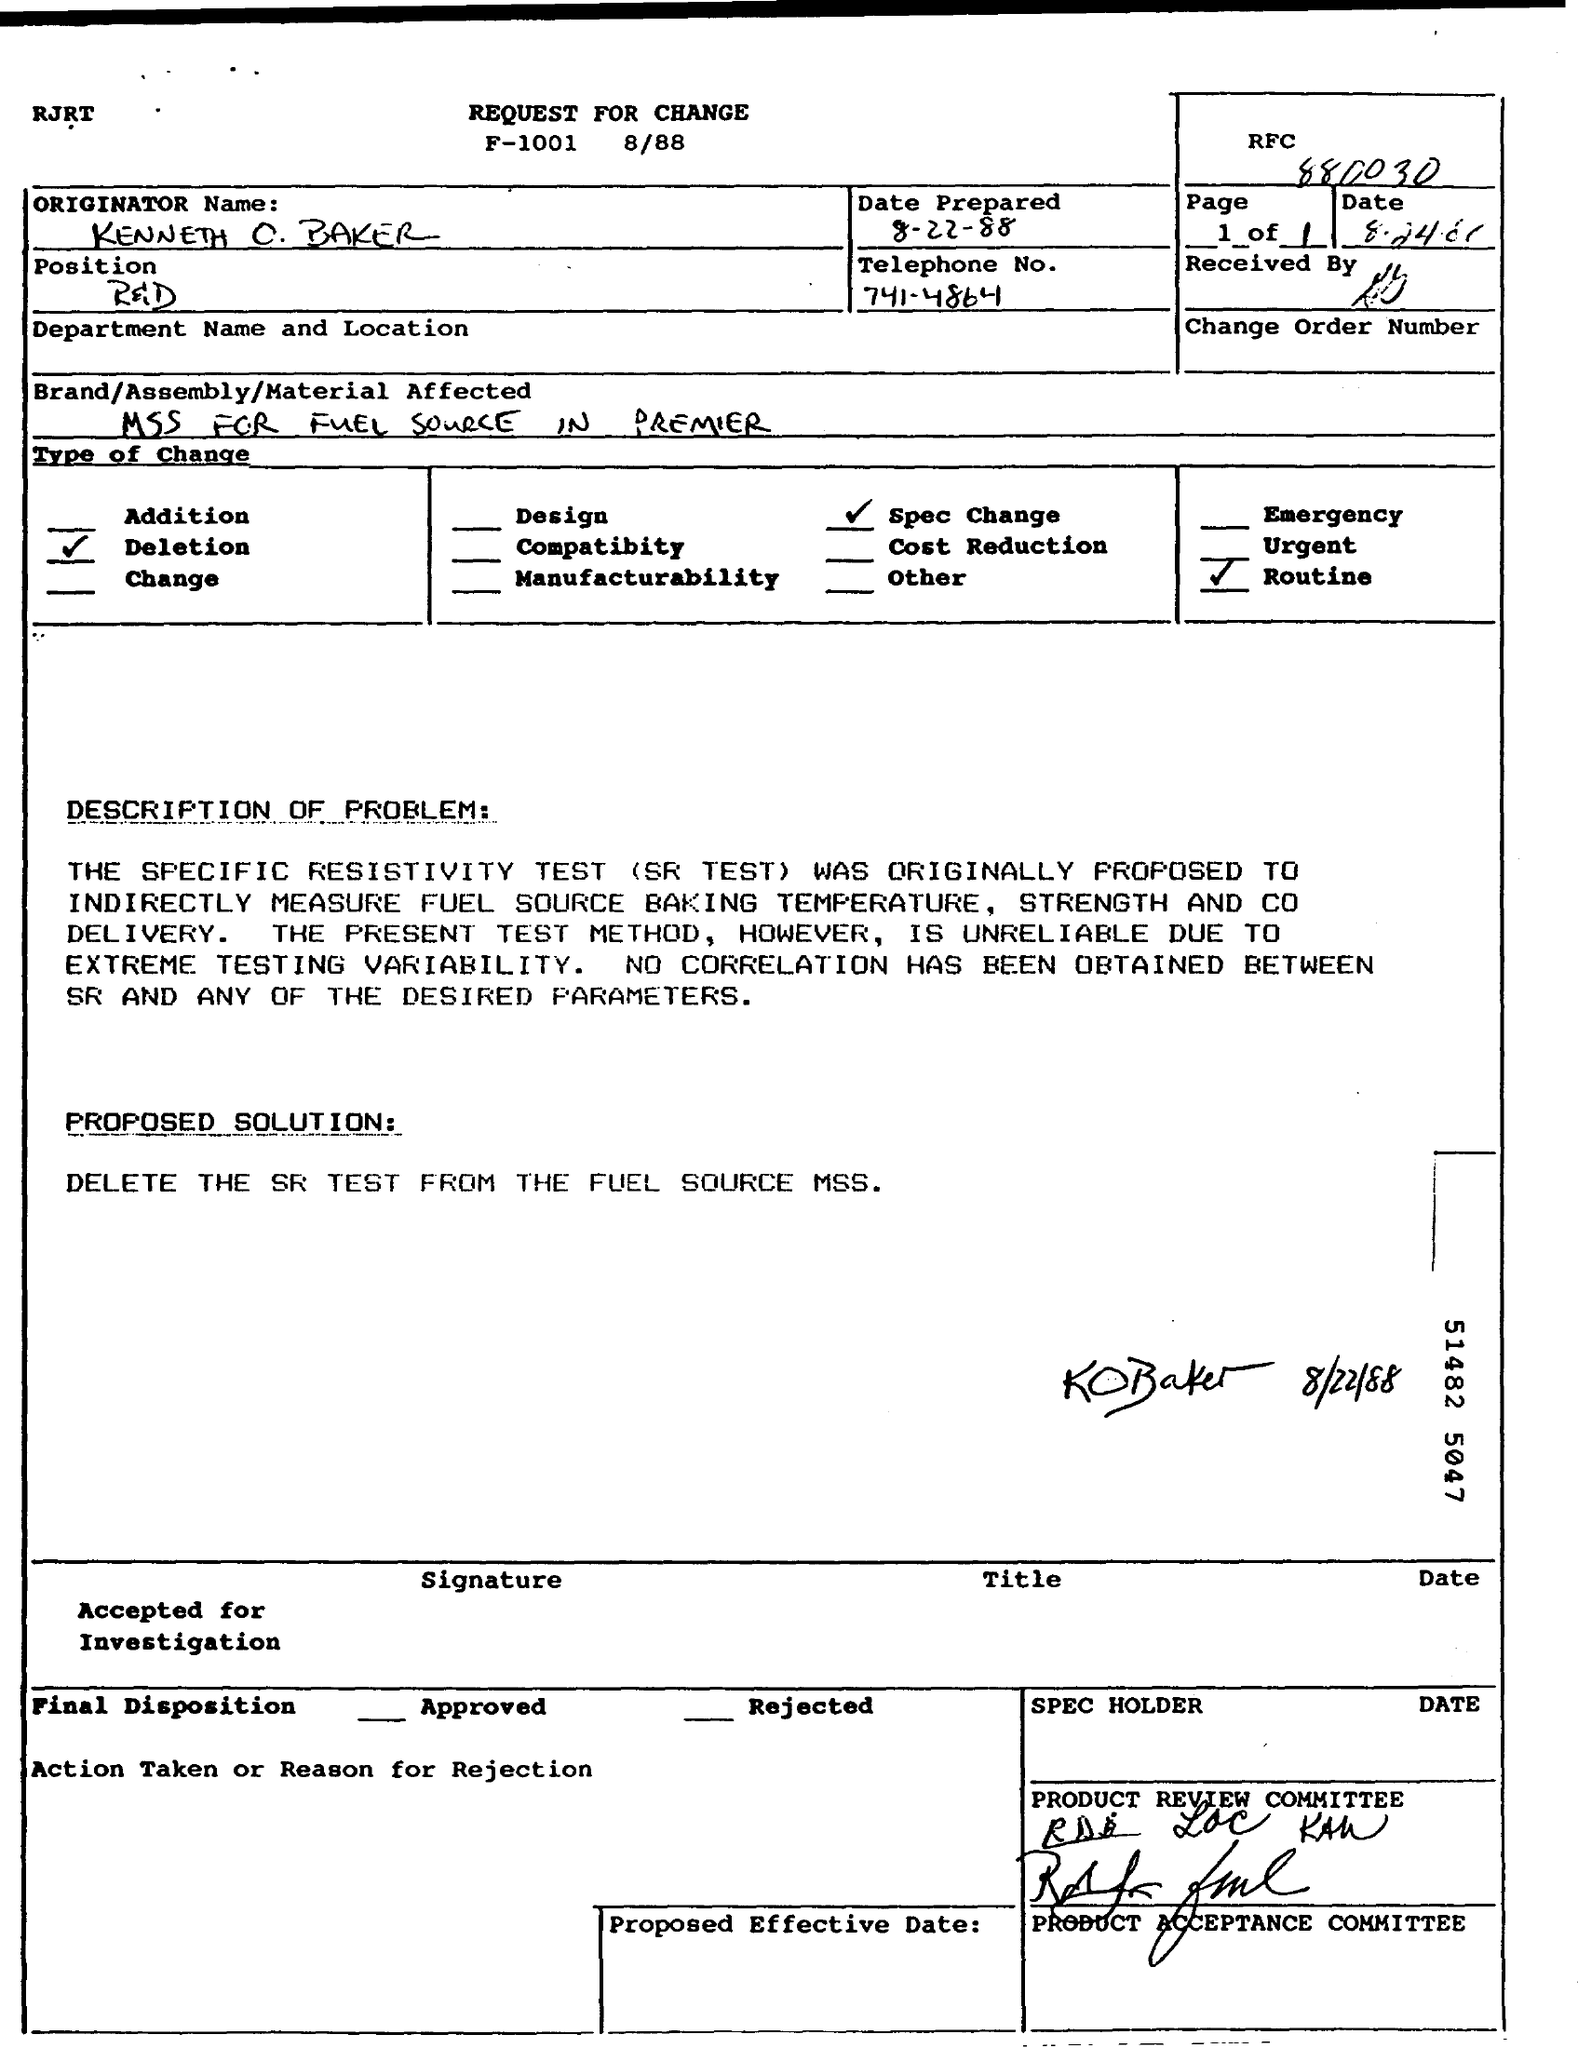What is the proposed solution on this document? The proposed solution as indicated on the document is to delete the SR test from the fuel source MSS due to its unreliability and lack of correlation with the desired parameters. Are there any signatures on the document? Yes, the document contains signatures within the 'PROPOSED SOLUTION' section and the bottom section titled 'SPEC HOLDER.' These signatures are part of the approval process for the change request. 